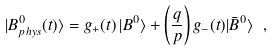<formula> <loc_0><loc_0><loc_500><loc_500>| B ^ { 0 } _ { p h y s } ( t ) \rangle = g _ { + } ( t ) \, | B ^ { 0 } \rangle + \left ( \frac { q } { p } \right ) g _ { - } ( t ) | \bar { B } ^ { 0 } \rangle \ ,</formula> 